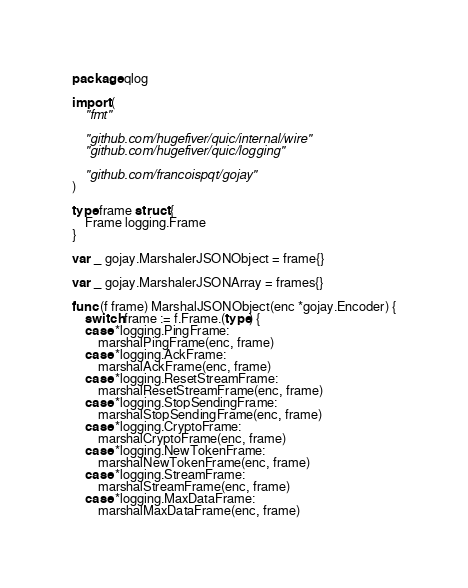<code> <loc_0><loc_0><loc_500><loc_500><_Go_>package qlog

import (
	"fmt"

	"github.com/hugefiver/quic/internal/wire"
	"github.com/hugefiver/quic/logging"

	"github.com/francoispqt/gojay"
)

type frame struct {
	Frame logging.Frame
}

var _ gojay.MarshalerJSONObject = frame{}

var _ gojay.MarshalerJSONArray = frames{}

func (f frame) MarshalJSONObject(enc *gojay.Encoder) {
	switch frame := f.Frame.(type) {
	case *logging.PingFrame:
		marshalPingFrame(enc, frame)
	case *logging.AckFrame:
		marshalAckFrame(enc, frame)
	case *logging.ResetStreamFrame:
		marshalResetStreamFrame(enc, frame)
	case *logging.StopSendingFrame:
		marshalStopSendingFrame(enc, frame)
	case *logging.CryptoFrame:
		marshalCryptoFrame(enc, frame)
	case *logging.NewTokenFrame:
		marshalNewTokenFrame(enc, frame)
	case *logging.StreamFrame:
		marshalStreamFrame(enc, frame)
	case *logging.MaxDataFrame:
		marshalMaxDataFrame(enc, frame)</code> 